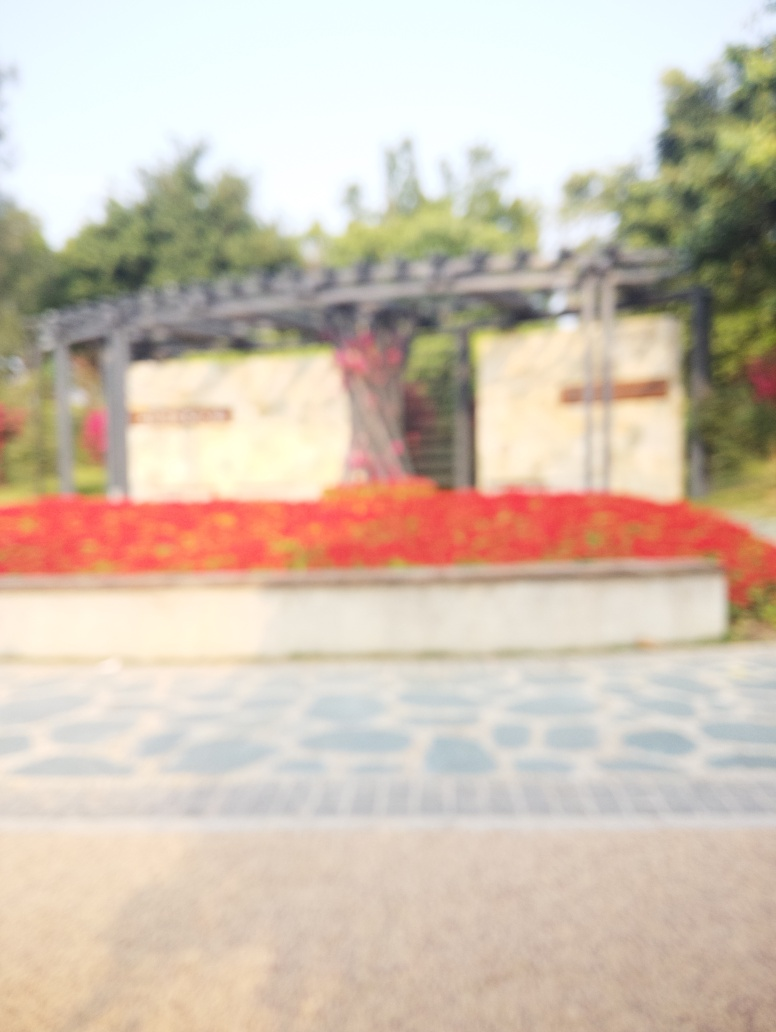Is the white balance off? It's not possible to accurately assess the white balance due to the image being out of focus. Proper evaluation of white balance requires a clear image where true white elements can be distinguished. 